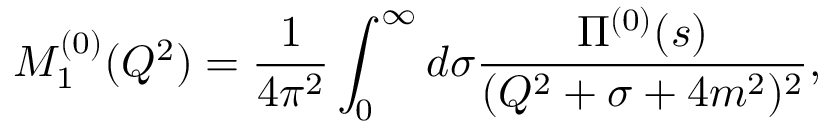Convert formula to latex. <formula><loc_0><loc_0><loc_500><loc_500>M _ { 1 } ^ { ( 0 ) } ( Q ^ { 2 } ) = \frac { 1 } { 4 \pi ^ { 2 } } \int _ { 0 } ^ { \infty } d \sigma \frac { \Pi ^ { ( 0 ) } ( s ) } { ( Q ^ { 2 } + \sigma + 4 m ^ { 2 } ) ^ { 2 } } ,</formula> 